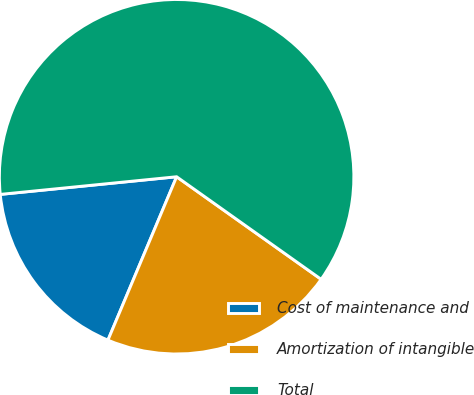Convert chart. <chart><loc_0><loc_0><loc_500><loc_500><pie_chart><fcel>Cost of maintenance and<fcel>Amortization of intangible<fcel>Total<nl><fcel>17.08%<fcel>21.51%<fcel>61.41%<nl></chart> 